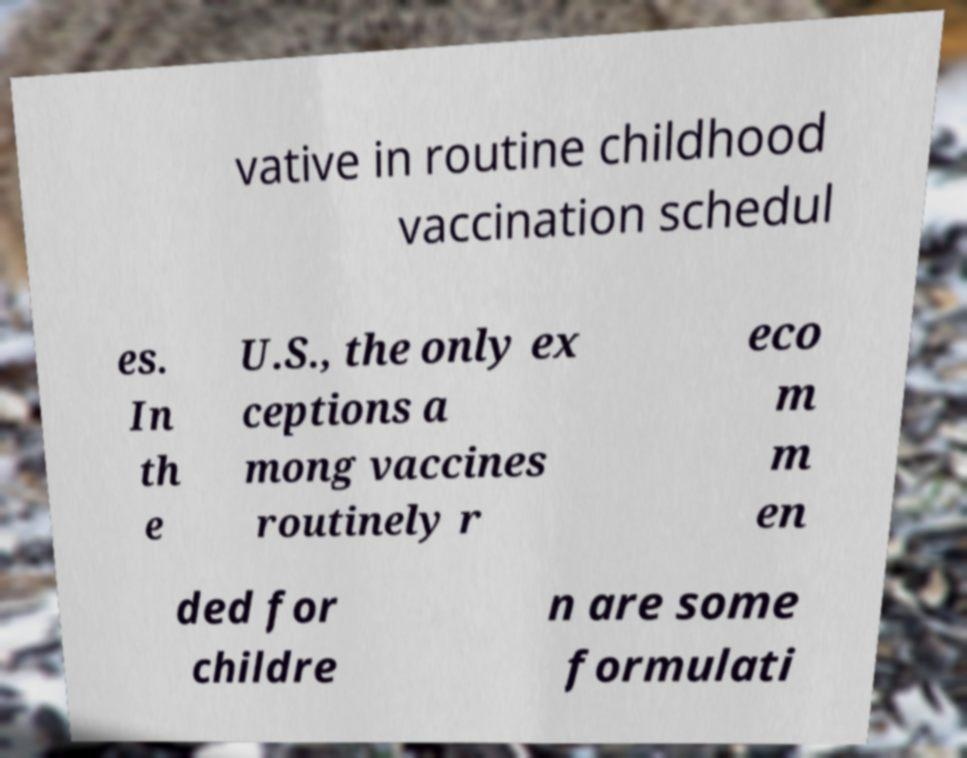Can you read and provide the text displayed in the image?This photo seems to have some interesting text. Can you extract and type it out for me? vative in routine childhood vaccination schedul es. In th e U.S., the only ex ceptions a mong vaccines routinely r eco m m en ded for childre n are some formulati 